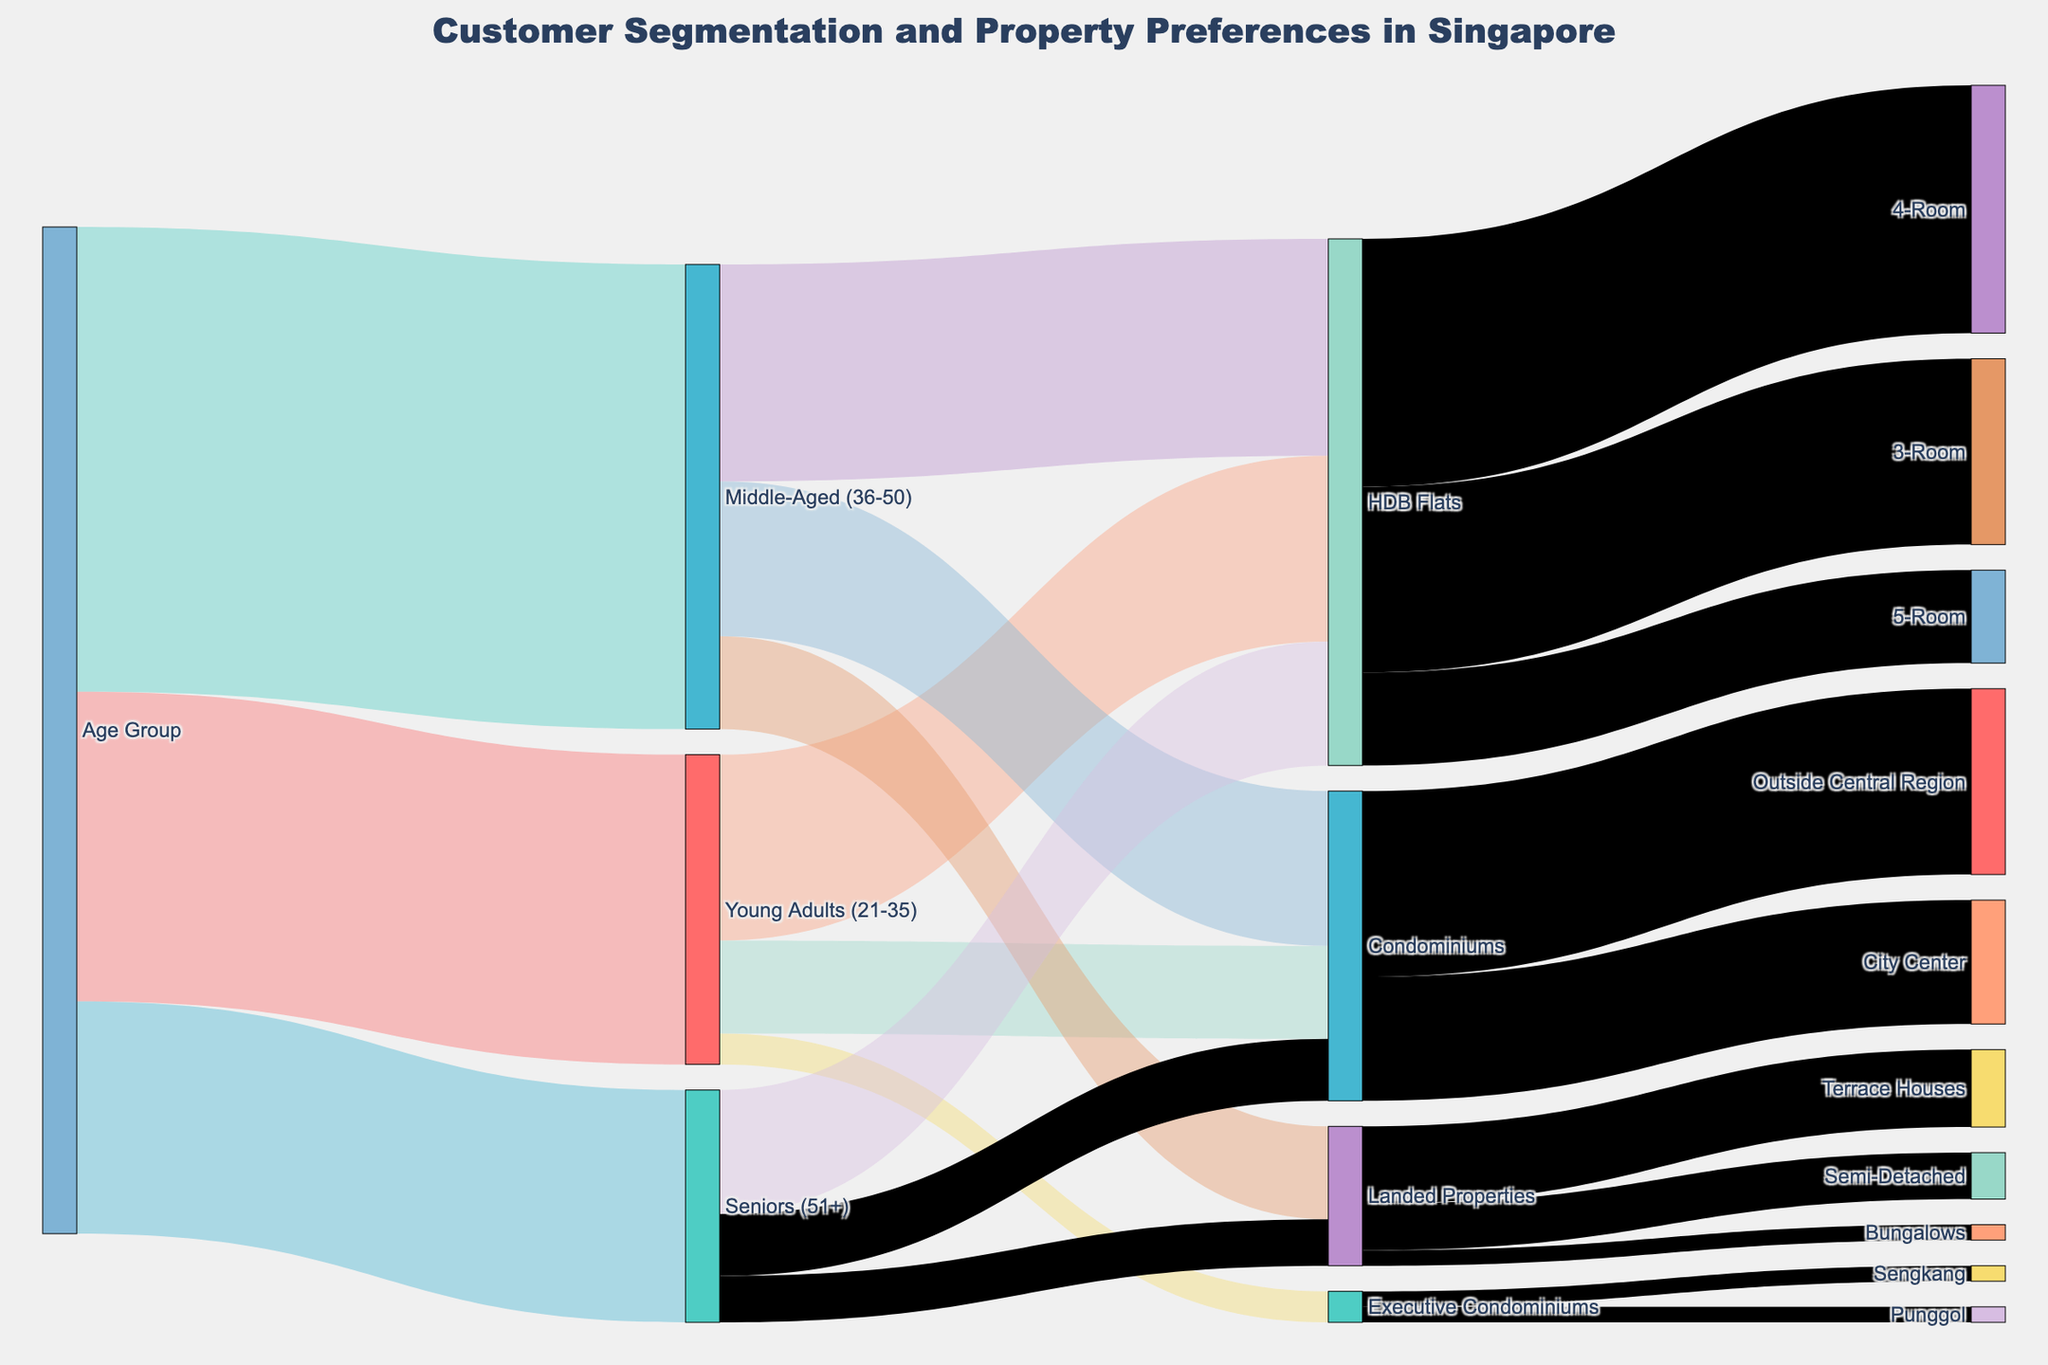What's the most preferred property type for Young Adults (21-35)? To answer this, look at the connections originating from "Young Adults (21-35)" in the Sankey diagram. The thickest link goes to "HDB Flats" with a value of 60.
Answer: HDB Flats How many Seniors (51+) prefer Condominiums? Identify the connection from "Seniors (51+)" to "Condominiums" in the Sankey diagram. The connection value is 20.
Answer: 20 Which age group has the highest number of customers? Look at the thickness and the value of the links emanating from the "Age Group". "Middle-Aged (36-50)" has a value of 150, which is the highest.
Answer: Middle-Aged (36-50) What percentage of HDB Flats choose a 4-Room configuration? From the diagram, 4-Room has a value of 80, and the total for HDB Flats is 60 (3-Room) + 80 (4-Room) + 30 (5-Room) = 170. So, (80/170) * 100% = 47.1%.
Answer: 47.1% How many people prefer staying in Executive Condominiums in Sengkang? Find the link from "Executive Condominiums" to "Sengkang". The value for the connection is 5.
Answer: 5 Which type of Condominiums are more popular, City Center or Outside Central Region? Compare the values of the links. The "Outside Central Region" has a value of 60, whereas "City Center" has a value of 40, making "Outside Central Region" more popular.
Answer: Outside Central Region Sum of customers preferring landed properties across all age groups? Sum the values of landed property preferences from all age groups: 30 (Middle-Aged) + 15 (Seniors) = 45.
Answer: 45 Which HDB Flat type has the fewest customers? Identify the values for HDB Flat categories. "5-Room" has the lowest value of 30.
Answer: 5-Room What percentage of Middle-Aged (36-50) people prefer Condominiums? Look at the values from "Middle-Aged (36-50)": Condominiums (50) and the total (HDB Flats 70 + Condominiums 50 + Landed Properties 30 = 150). So, (50/150) * 100% = 33.3%.
Answer: 33.3% 